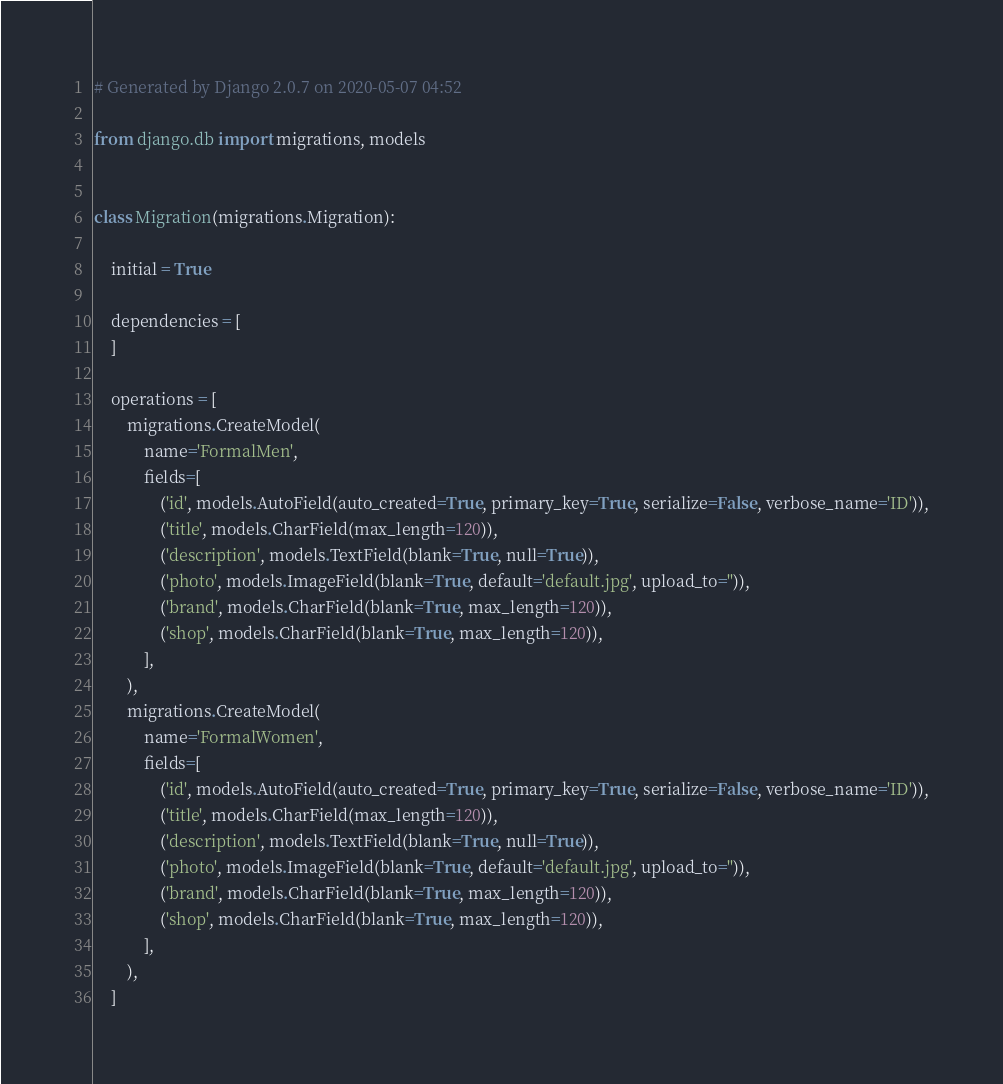Convert code to text. <code><loc_0><loc_0><loc_500><loc_500><_Python_># Generated by Django 2.0.7 on 2020-05-07 04:52

from django.db import migrations, models


class Migration(migrations.Migration):

    initial = True

    dependencies = [
    ]

    operations = [
        migrations.CreateModel(
            name='FormalMen',
            fields=[
                ('id', models.AutoField(auto_created=True, primary_key=True, serialize=False, verbose_name='ID')),
                ('title', models.CharField(max_length=120)),
                ('description', models.TextField(blank=True, null=True)),
                ('photo', models.ImageField(blank=True, default='default.jpg', upload_to='')),
                ('brand', models.CharField(blank=True, max_length=120)),
                ('shop', models.CharField(blank=True, max_length=120)),
            ],
        ),
        migrations.CreateModel(
            name='FormalWomen',
            fields=[
                ('id', models.AutoField(auto_created=True, primary_key=True, serialize=False, verbose_name='ID')),
                ('title', models.CharField(max_length=120)),
                ('description', models.TextField(blank=True, null=True)),
                ('photo', models.ImageField(blank=True, default='default.jpg', upload_to='')),
                ('brand', models.CharField(blank=True, max_length=120)),
                ('shop', models.CharField(blank=True, max_length=120)),
            ],
        ),
    ]
</code> 